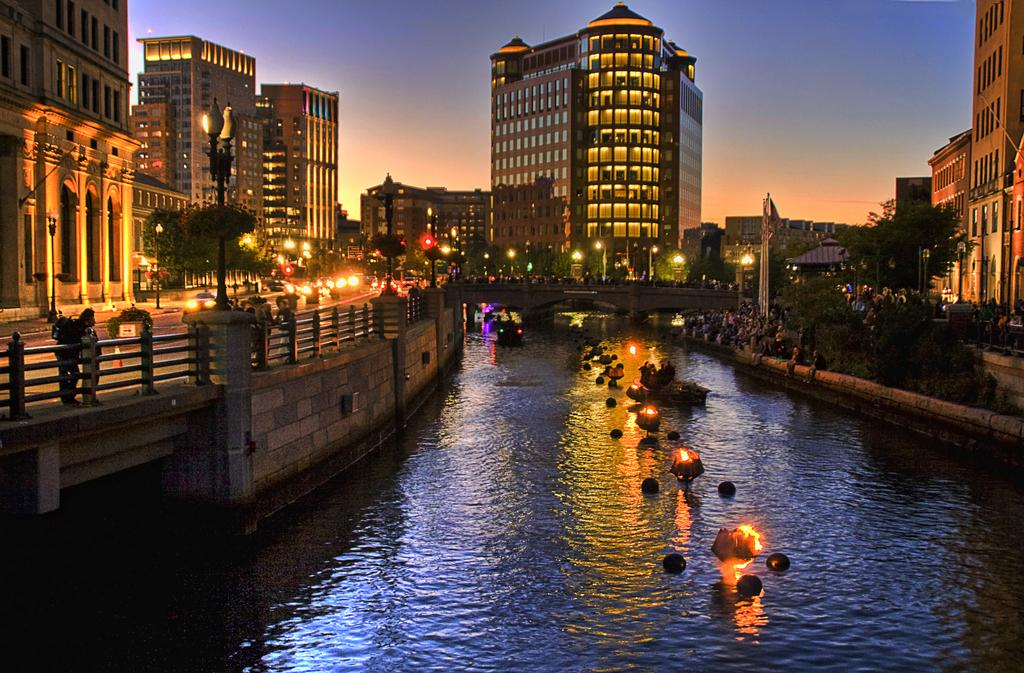What is on the water in the image? There are objects on the water in the image. What can be seen illuminating the scene in the image? There are lights visible in the image. What structures are present in the image? There are poles, buildings, and trees in the image. Who or what is present in the image? There is a group of people in the image. What is visible in the background of the image? The sky is visible in the background of the image. What type of hat is the sun wearing in the image? There is no sun or hat present in the image. How many trains are visible in the image? There are no trains visible in the image. 